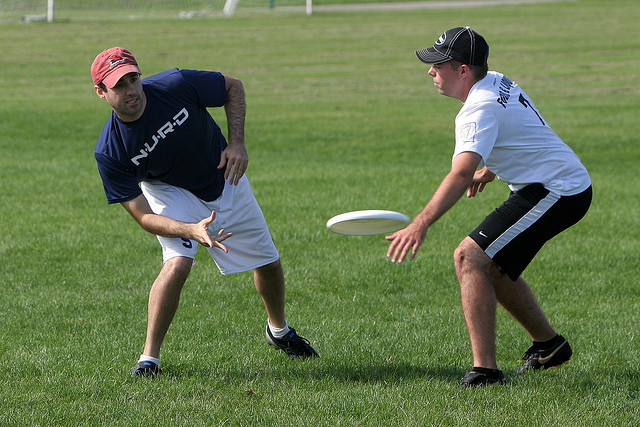Please identify all text content in this image. NURD 7 